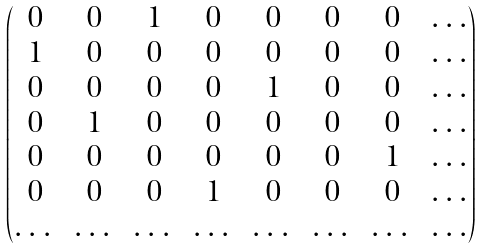<formula> <loc_0><loc_0><loc_500><loc_500>\begin{pmatrix} 0 & 0 & 1 & 0 & 0 & 0 & 0 & \dots \\ 1 & 0 & 0 & 0 & 0 & 0 & 0 & \dots \\ 0 & 0 & 0 & 0 & 1 & 0 & 0 & \dots \\ 0 & 1 & 0 & 0 & 0 & 0 & 0 & \dots \\ 0 & 0 & 0 & 0 & 0 & 0 & 1 & \dots \\ 0 & 0 & 0 & 1 & 0 & 0 & 0 & \dots \\ \dots & \dots & \dots & \dots & \dots & \dots & \dots & \dots \end{pmatrix}</formula> 